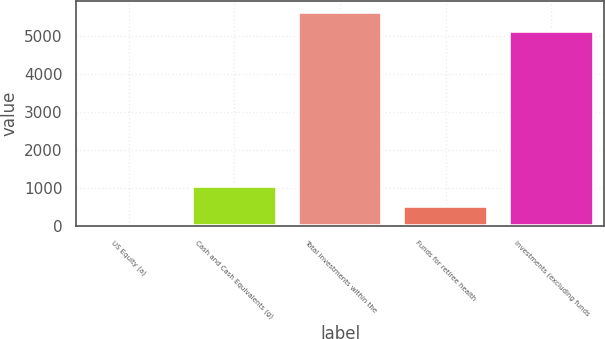Convert chart to OTSL. <chart><loc_0><loc_0><loc_500><loc_500><bar_chart><fcel>US Equity (a)<fcel>Cash and Cash Equivalents (g)<fcel>Total investments within the<fcel>Funds for retiree health<fcel>Investments (excluding funds<nl><fcel>10<fcel>1047.6<fcel>5630.8<fcel>528.8<fcel>5112<nl></chart> 